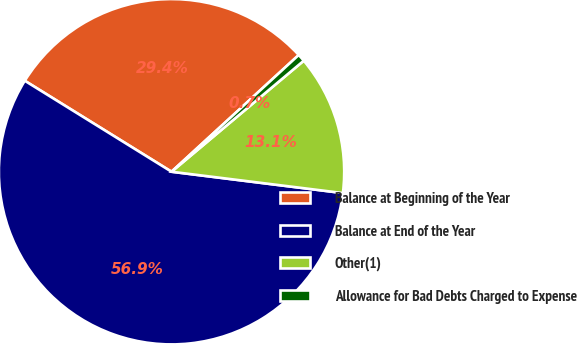Convert chart to OTSL. <chart><loc_0><loc_0><loc_500><loc_500><pie_chart><fcel>Balance at Beginning of the Year<fcel>Balance at End of the Year<fcel>Other(1)<fcel>Allowance for Bad Debts Charged to Expense<nl><fcel>29.35%<fcel>56.86%<fcel>13.09%<fcel>0.7%<nl></chart> 